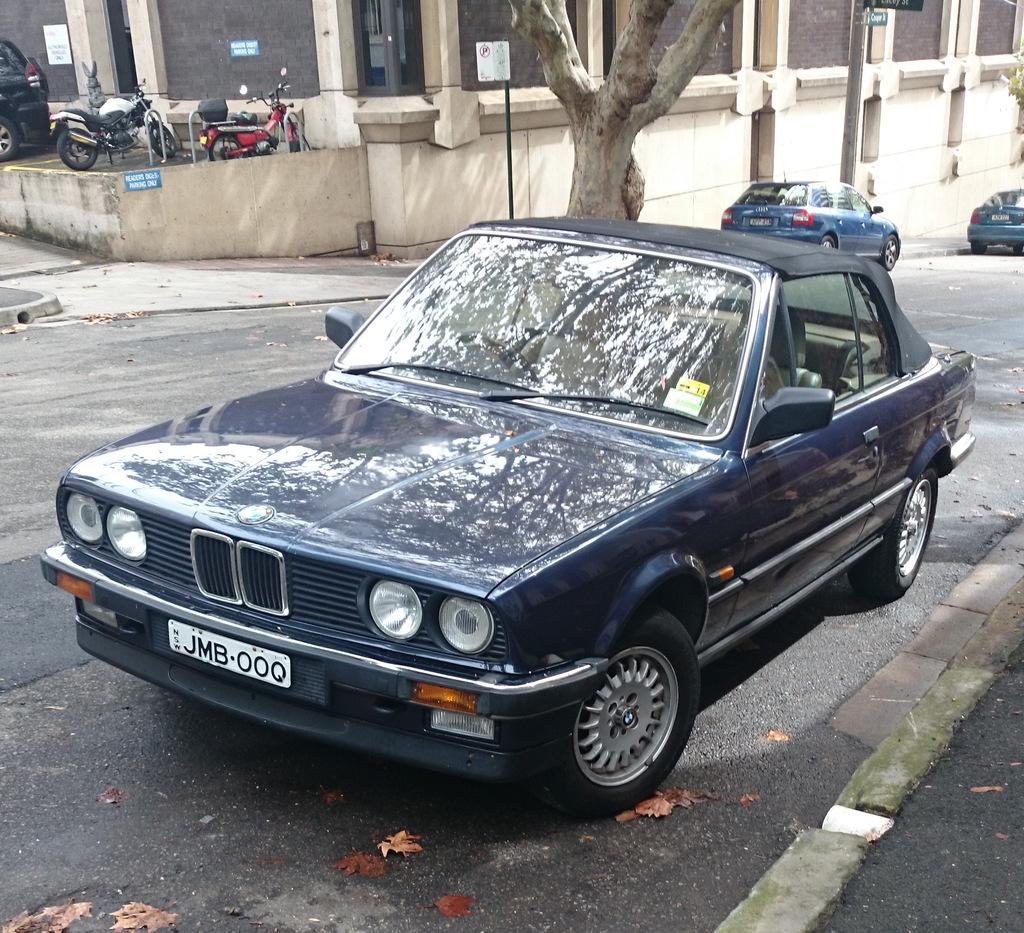Can you describe this image briefly? In this image we can see group of cars parked on the road. To the left side of the image we can see two motorcycles parked in a parking lot and in the background we can see pole,tree and a building. 